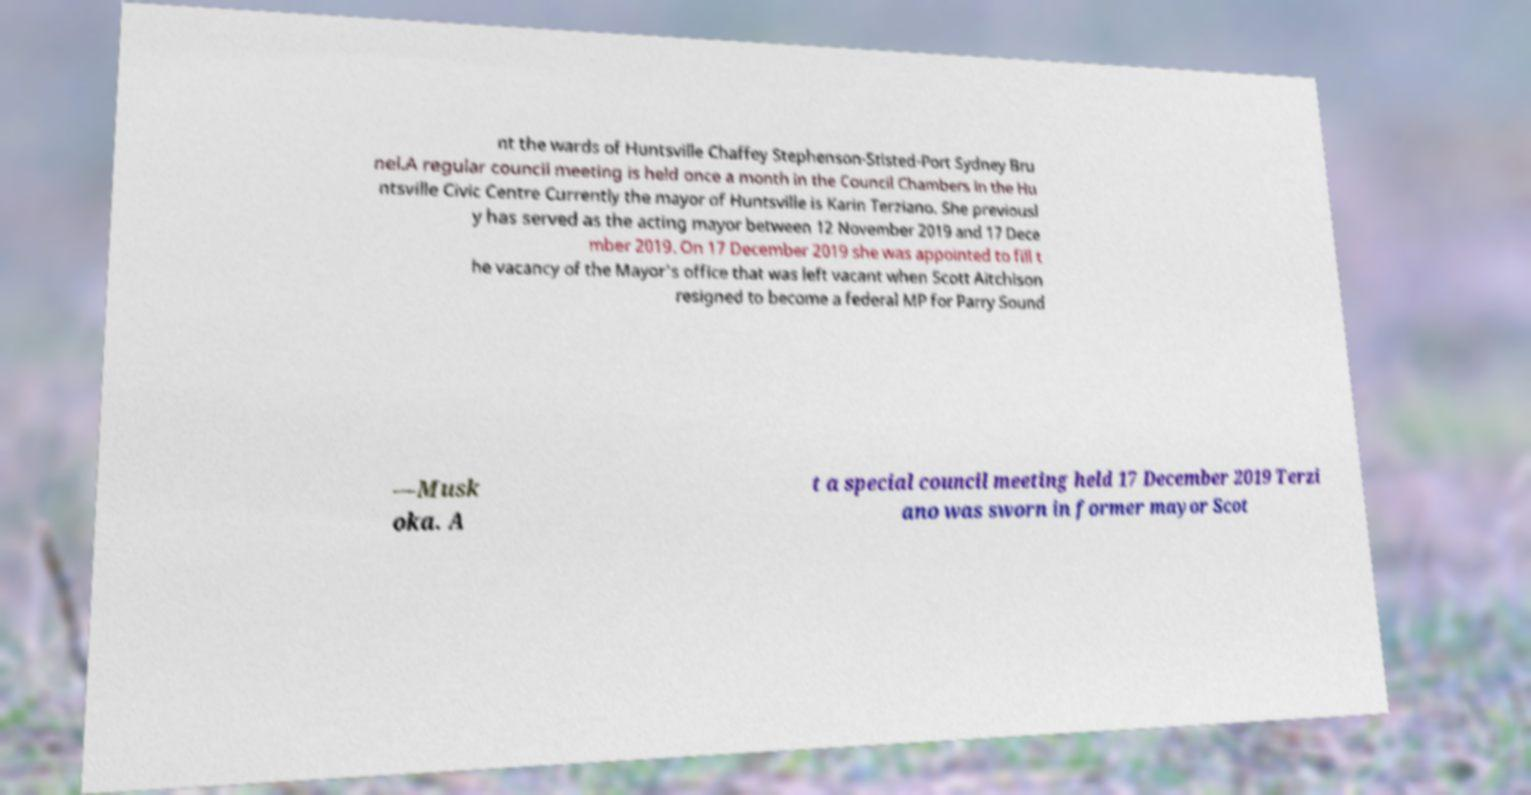What messages or text are displayed in this image? I need them in a readable, typed format. nt the wards of Huntsville Chaffey Stephenson-Stisted-Port Sydney Bru nel.A regular council meeting is held once a month in the Council Chambers in the Hu ntsville Civic Centre Currently the mayor of Huntsville is Karin Terziano. She previousl y has served as the acting mayor between 12 November 2019 and 17 Dece mber 2019. On 17 December 2019 she was appointed to fill t he vacancy of the Mayor's office that was left vacant when Scott Aitchison resigned to become a federal MP for Parry Sound —Musk oka. A t a special council meeting held 17 December 2019 Terzi ano was sworn in former mayor Scot 